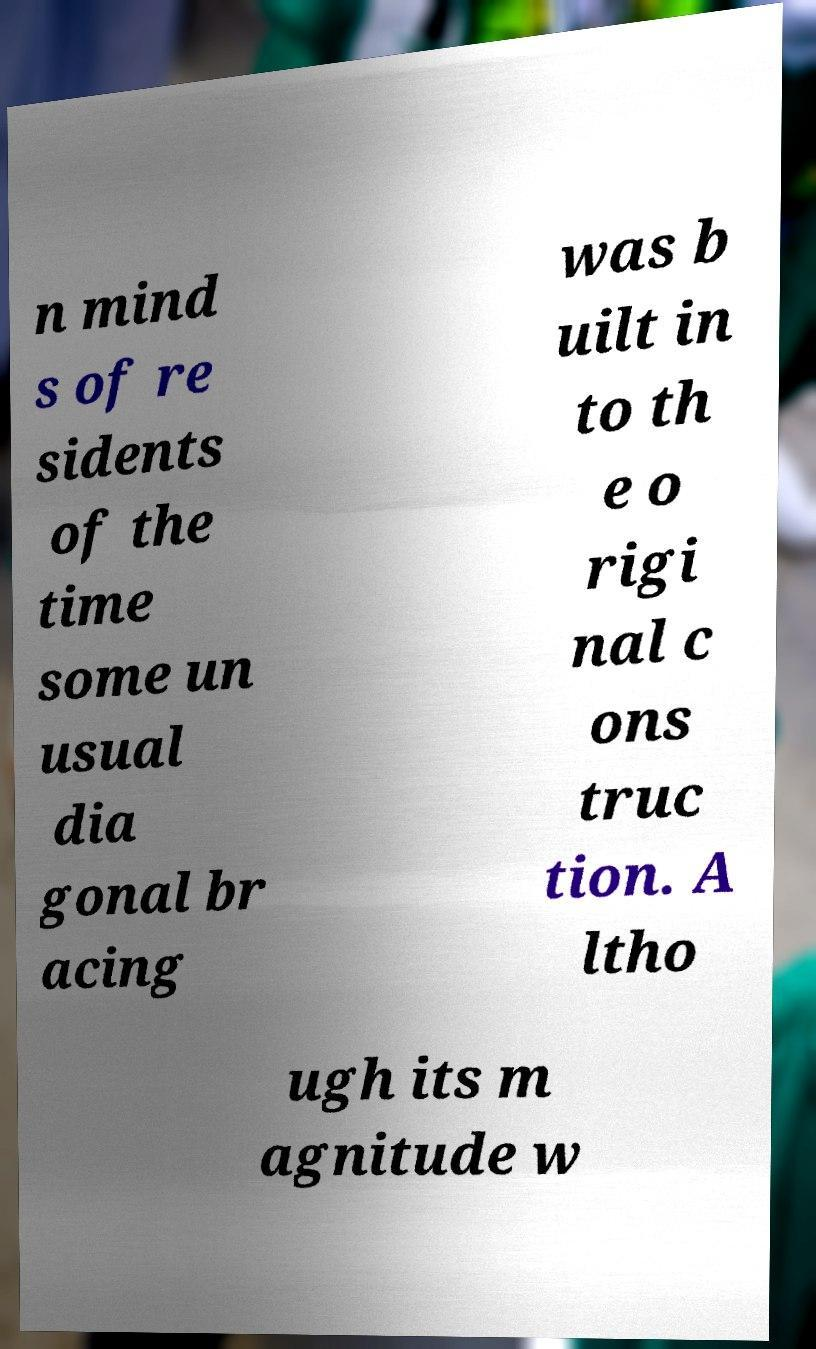Can you read and provide the text displayed in the image?This photo seems to have some interesting text. Can you extract and type it out for me? n mind s of re sidents of the time some un usual dia gonal br acing was b uilt in to th e o rigi nal c ons truc tion. A ltho ugh its m agnitude w 